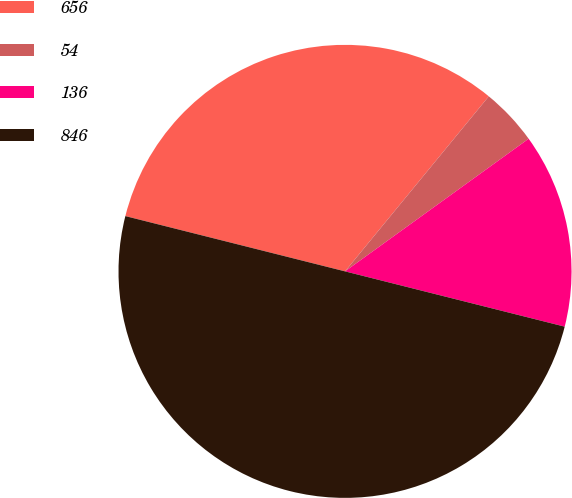Convert chart to OTSL. <chart><loc_0><loc_0><loc_500><loc_500><pie_chart><fcel>656<fcel>54<fcel>136<fcel>846<nl><fcel>32.02%<fcel>4.1%<fcel>13.88%<fcel>50.0%<nl></chart> 